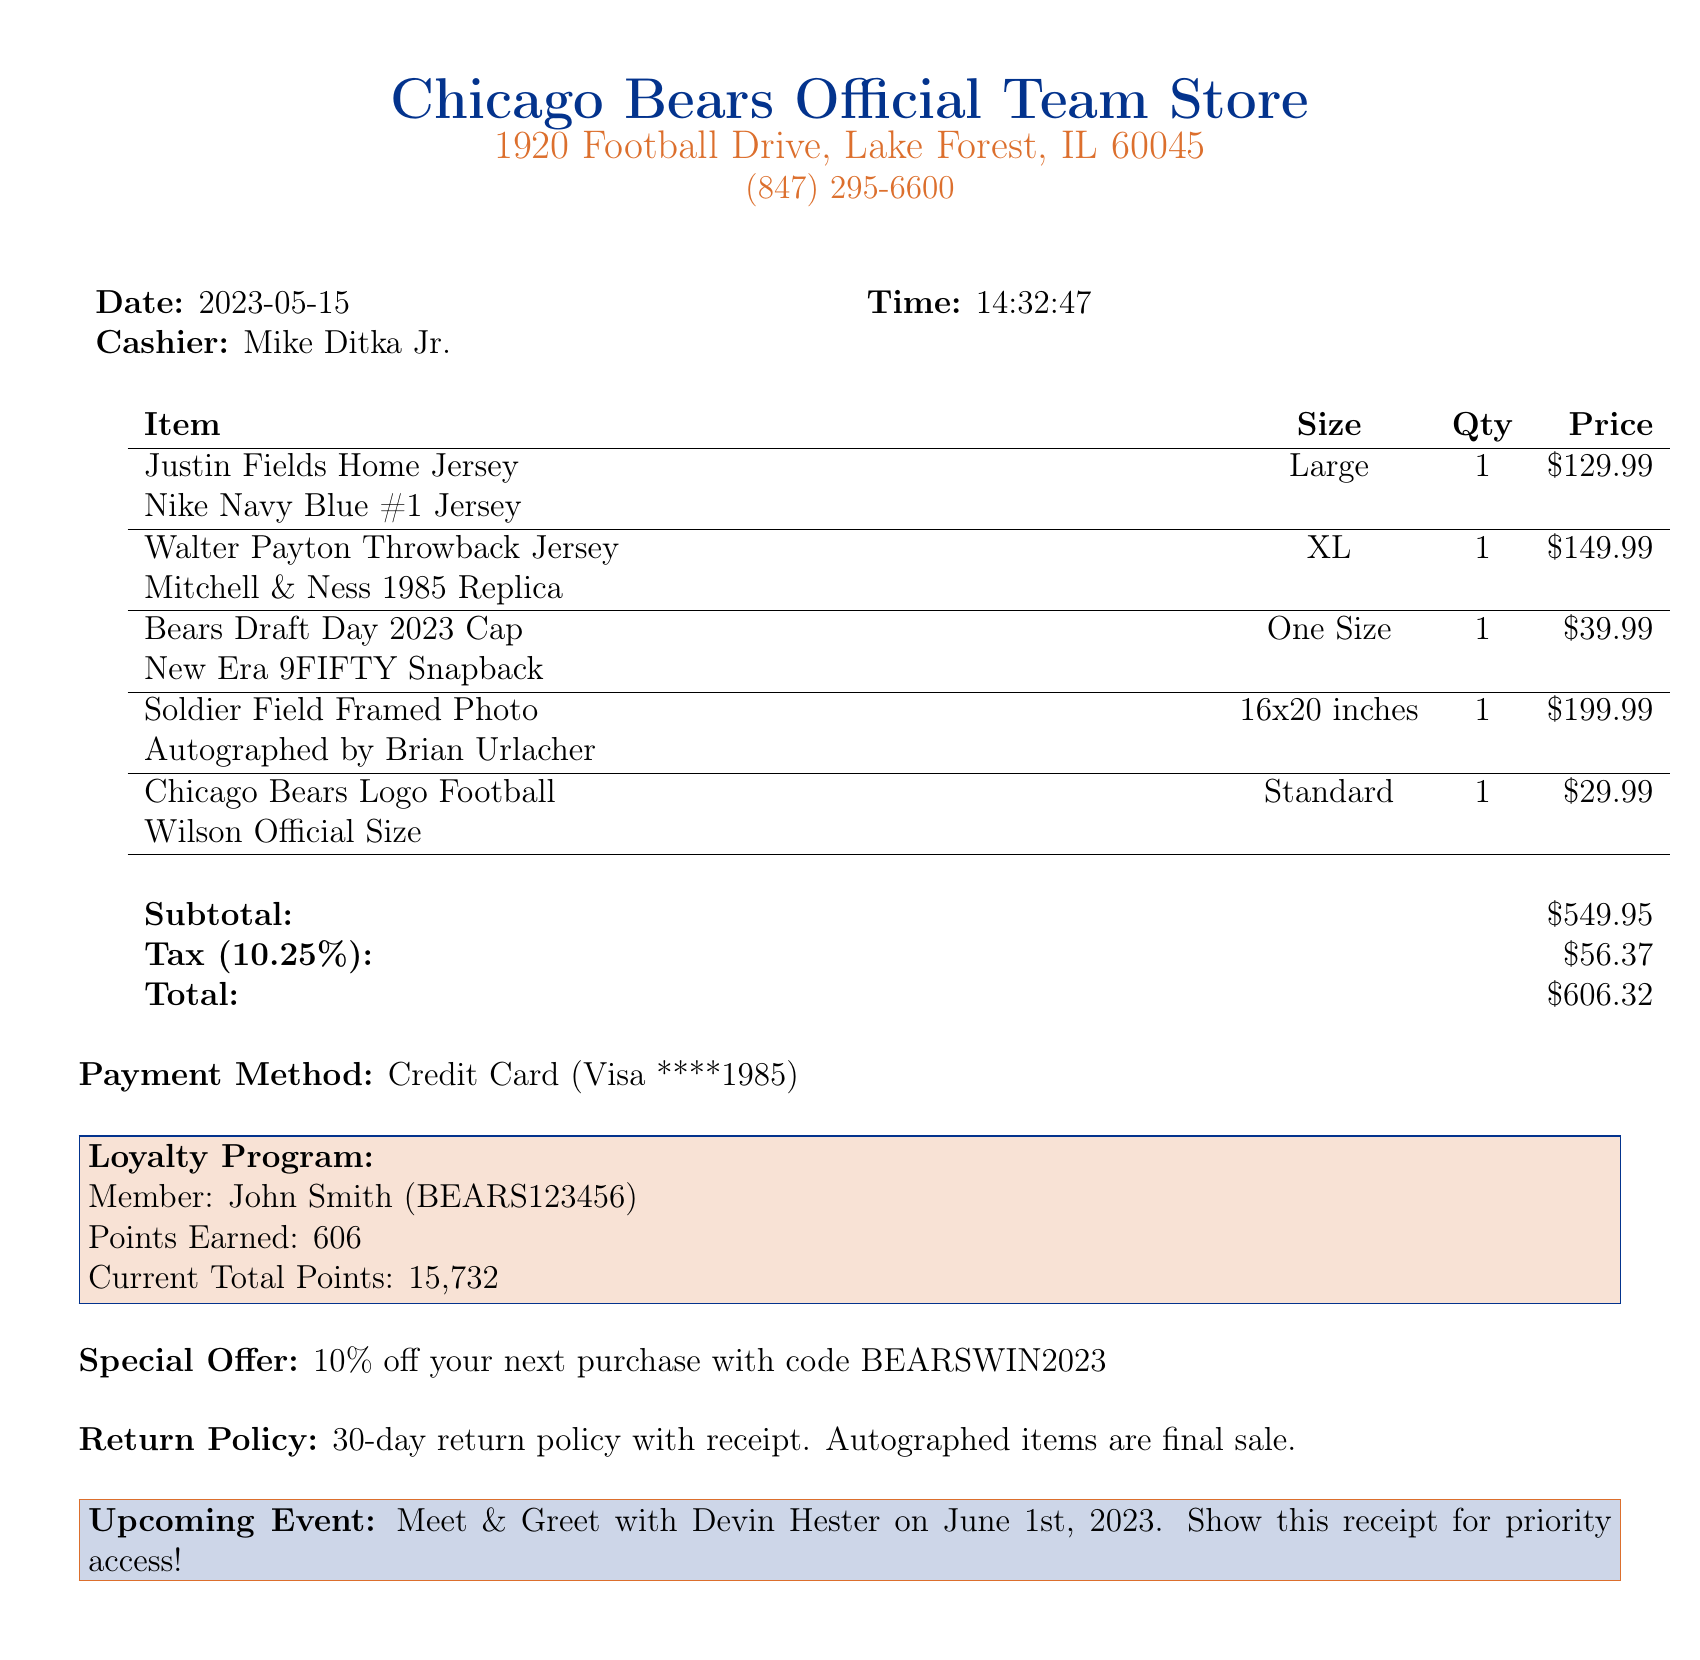What is the transaction date? The transaction date is explicitly stated in the document as the date when the purchase was made.
Answer: 2023-05-15 Who was the cashier for the transaction? The cashier's name is provided in the document, indicating who assisted with the purchase.
Answer: Mike Ditka Jr What is the price of the Justin Fields Home Jersey? The price for the specific item is listed in the document, showing the cost of that jersey.
Answer: $129.99 What is the size of the Walter Payton Throwback Jersey? The size of this jersey is noted in the item description section of the document.
Answer: XL How much was the tax amount charged? The tax amount is calculated based on the subtotal and is clearly shown in the document.
Answer: $56.37 What is the total amount paid for the merchandise? The total shows the final amount including subtotal and tax in the receipt.
Answer: $606.32 What is the special offer mentioned in the document? A promotional offer is listed in the document, encouraging future purchases.
Answer: 10% off your next purchase with code BEARSWIN2023 What is the return policy for the purchased items? The document specifies the guidelines for returns and what items cannot be returned.
Answer: 30-day return policy with receipt. Autographed items are final sale How many loyalty points were earned from this transaction? The document provides information on the points earned from this specific purchase.
Answer: 606 When is the upcoming event mentioned in the receipt? The receipt includes details about an event featuring a notable player, which is highlighted in the document.
Answer: June 1st, 2023 